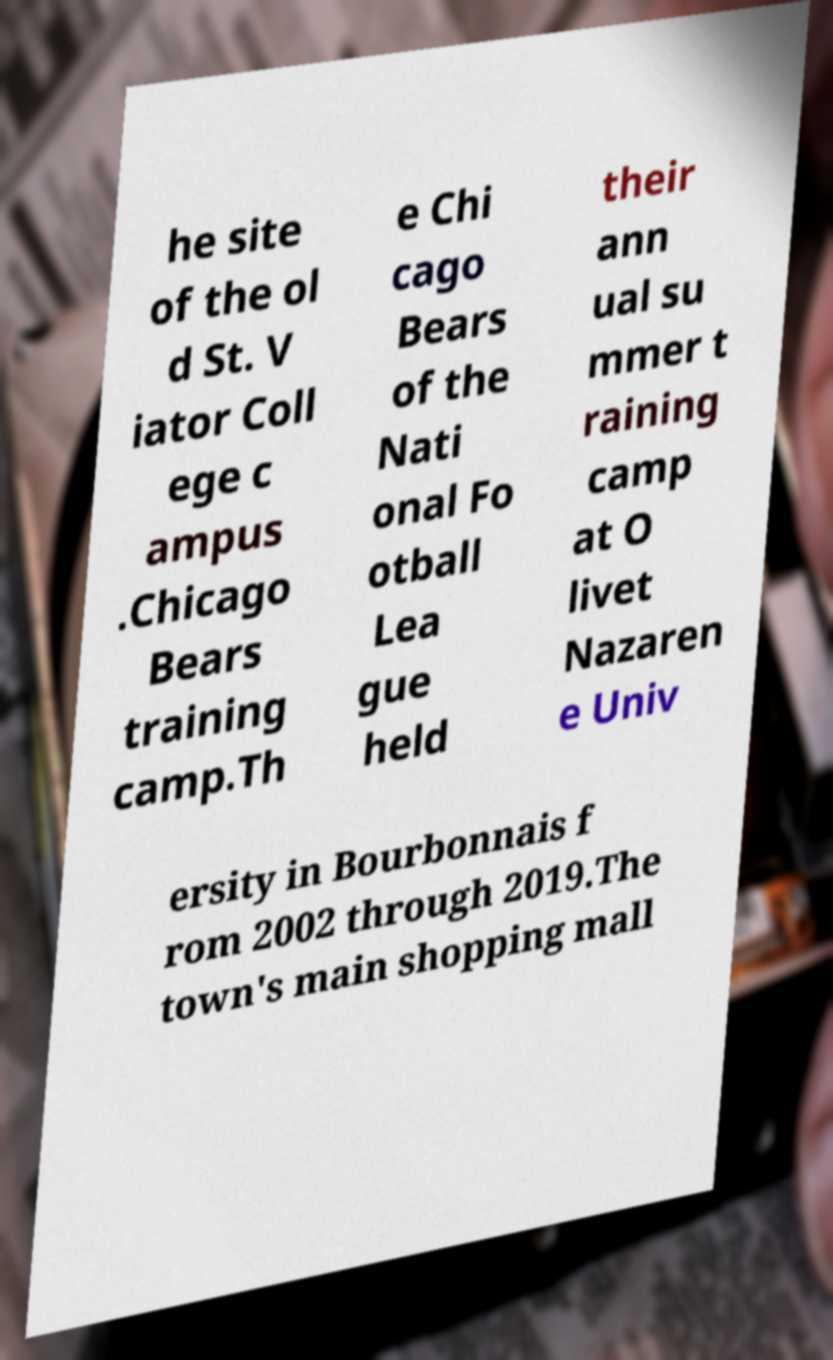Please read and relay the text visible in this image. What does it say? he site of the ol d St. V iator Coll ege c ampus .Chicago Bears training camp.Th e Chi cago Bears of the Nati onal Fo otball Lea gue held their ann ual su mmer t raining camp at O livet Nazaren e Univ ersity in Bourbonnais f rom 2002 through 2019.The town's main shopping mall 